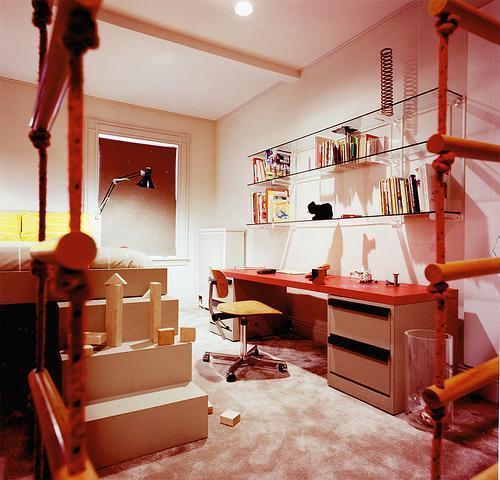Who uses this room?
Choose the right answer from the provided options to respond to the question.
Options: Older adult, child, teenager, young adult. Child. 